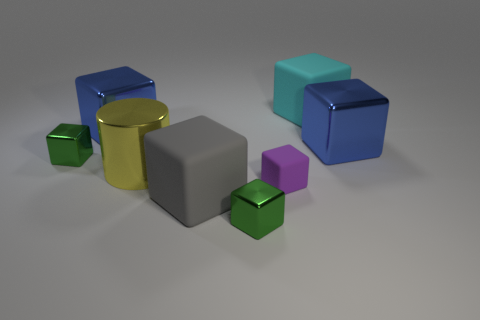Do the large cyan matte object and the purple rubber object have the same shape?
Your answer should be very brief. Yes. What number of tiny green objects are on the right side of the large yellow cylinder and behind the big cylinder?
Offer a very short reply. 0. Are there any other things that are the same size as the purple rubber thing?
Ensure brevity in your answer.  Yes. Are there more cubes in front of the tiny purple thing than big blue cubes that are on the left side of the big cyan matte block?
Your answer should be very brief. Yes. There is a big blue thing that is on the left side of the tiny matte object; what is it made of?
Your answer should be very brief. Metal. There is a big gray thing; is its shape the same as the big yellow shiny thing that is in front of the cyan rubber thing?
Give a very brief answer. No. What number of large blue things are left of the tiny green metallic object to the left of the large blue block to the left of the shiny cylinder?
Offer a terse response. 0. What color is the other big rubber thing that is the same shape as the cyan matte thing?
Keep it short and to the point. Gray. Is there anything else that is the same shape as the large yellow thing?
Make the answer very short. No. How many balls are either tiny purple things or big objects?
Keep it short and to the point. 0. 